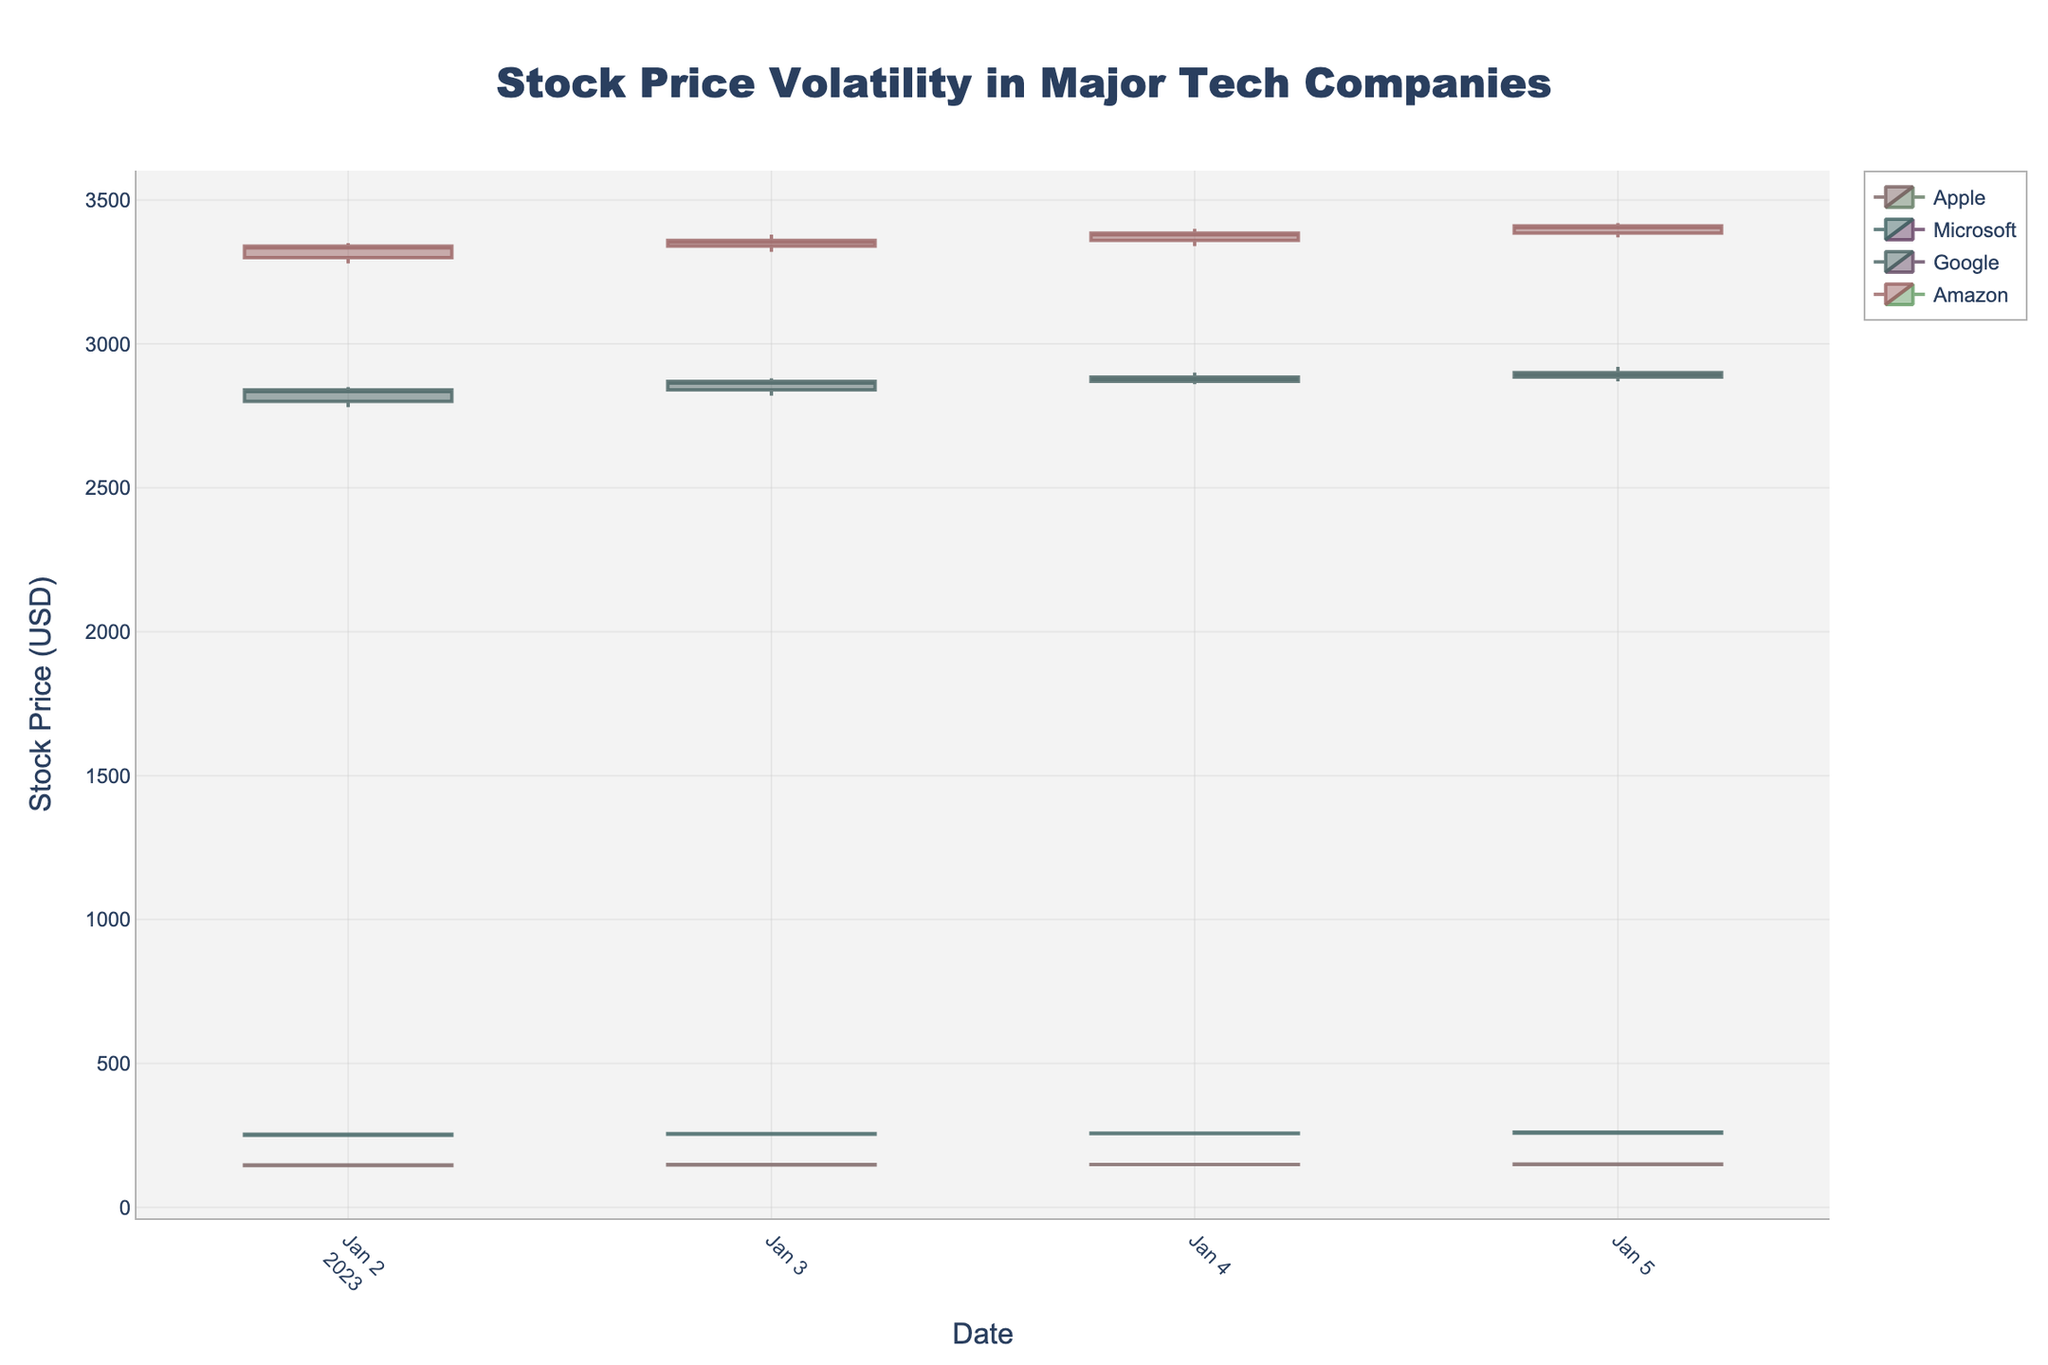How many tech companies are compared in the plot? The title mentions "Major Tech Companies," and upon closer inspection, the legend shows four different companies represented in different colors.
Answer: 4 What is the highest stock price for Google during the given dates? By examining the candlestick plot for Google, the highest value on the y-axis (which represents the stock price) is 2920 on the last date.
Answer: 2920 Which company showed the smallest range in their stock price on the first date? By comparing the heights of the candlesticks on the first date for each company, Microsoft has the smallest range (from 248 to 255). The range is 7.
Answer: Microsoft What is the average closing price of Apple over the four days? To find the average, sum the closing prices for Apple (147.00, 148.50, 149.00, 150.00) and then divide by 4: (147.00 + 148.50 + 149.00 + 150.00) / 4 = 148.625
Answer: 148.625 Which company had the highest volume of trades on any given day, and what was that volume? By examining the volume bars beneath the candlesticks, the highest volume appears for Apple on 2023-01-02, with the volume being 90475600.
Answer: Apple, 90475600 On which date did Amazon's stock price remain relatively stable, and how can you tell? On 2023-01-04, Amazon's candlestick plot shows minimal difference between the opening and closing prices (from 3360 to 3385) with low volatility indicated by the short length of the candle body.
Answer: 2023-01-04 What is the median closing price for Microsoft for the given dates? The closing prices for Microsoft are 254.00, 256.00, 258.00, 261.00. The median can be found by taking the average of the middle two values in the sorted list: (256.00 + 258.00) / 2 = 257.00
Answer: 257.00 Which company had the largest increase in closing price over the given period? By calculating the difference between the closing prices on 2023-01-02 and 2023-01-05 for each company: 
- Apple: 150.00 - 147.00 = 3.00 
- Microsoft: 261.00 - 254.00 = 7.00 
- Google: 2900.00 - 2840.00 = 60.00 
- Amazon: 3410.00 - 3340.00 = 70.00 
Amazon has the highest increase of 70.
Answer: Amazon 